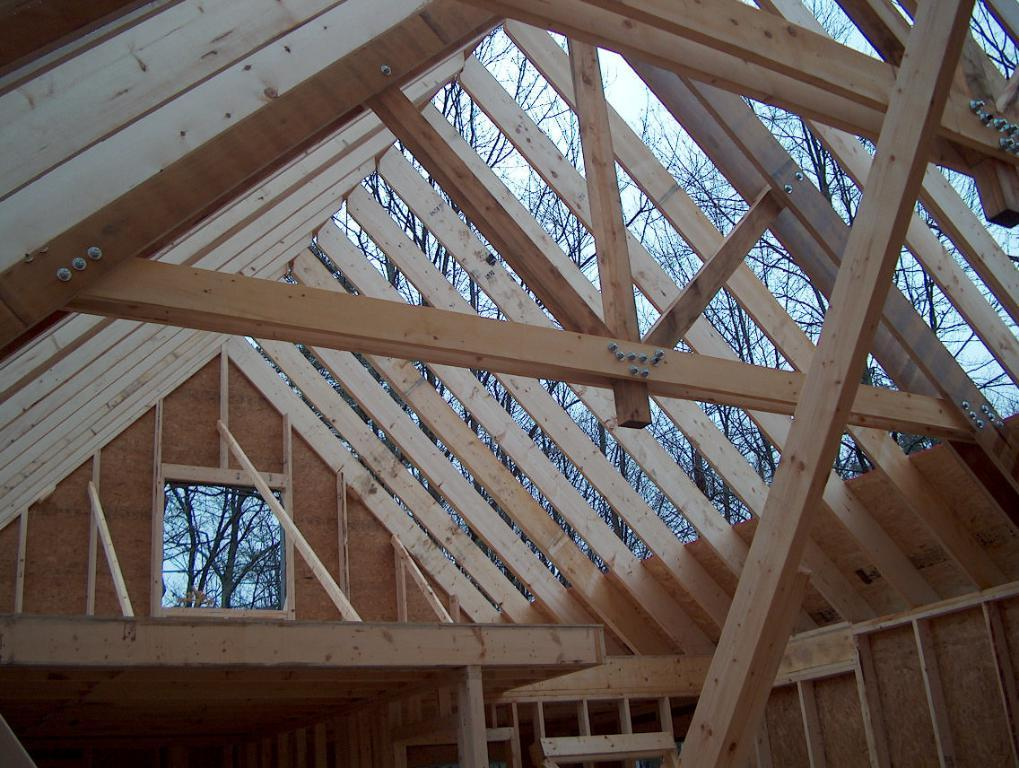What type of house is shown in the image? There is a wooden house in the image. Can you describe any specific features of the house? There is a window visible in the image. What can be seen in the background of the image? Trees are visible in the image. How would you describe the color of the sky in the image? The sky appears to be white in color. What is the level of experience of the beginner in the image? There is no reference to a beginner or any person in the image, so it is not possible to answer that question about their level of experience. 